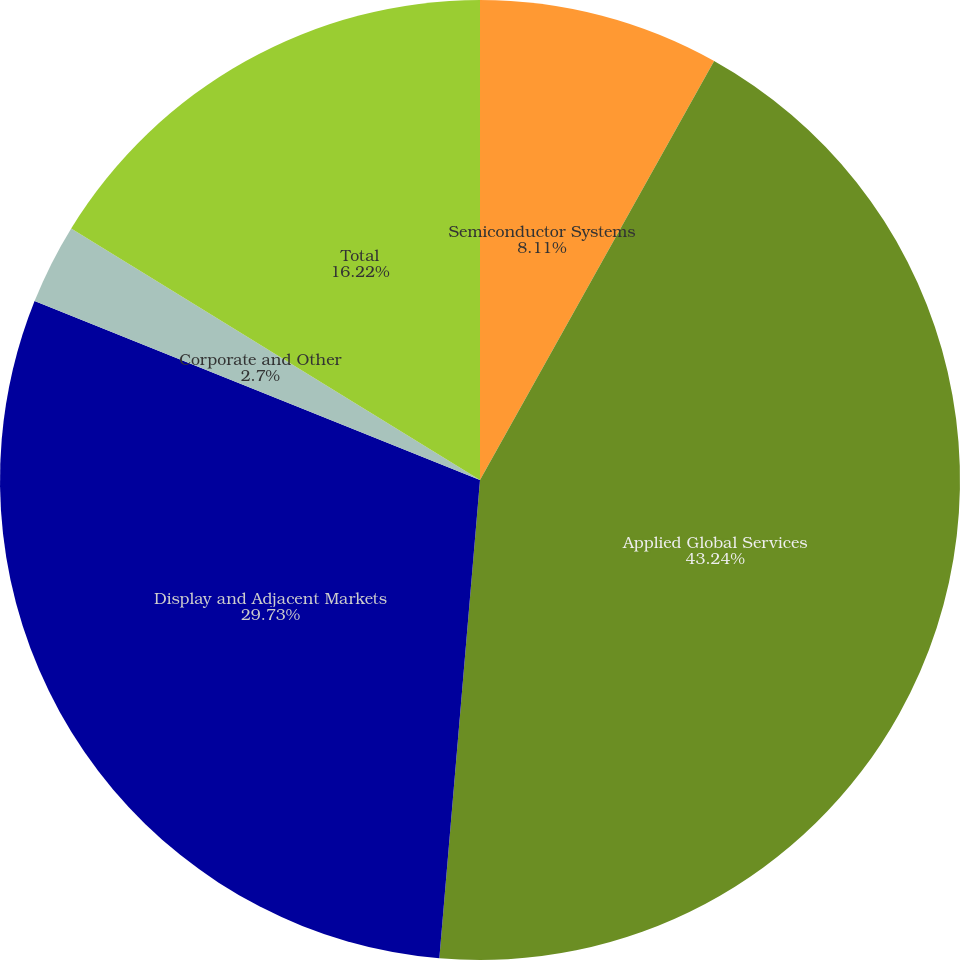<chart> <loc_0><loc_0><loc_500><loc_500><pie_chart><fcel>Semiconductor Systems<fcel>Applied Global Services<fcel>Display and Adjacent Markets<fcel>Corporate and Other<fcel>Total<nl><fcel>8.11%<fcel>43.24%<fcel>29.73%<fcel>2.7%<fcel>16.22%<nl></chart> 